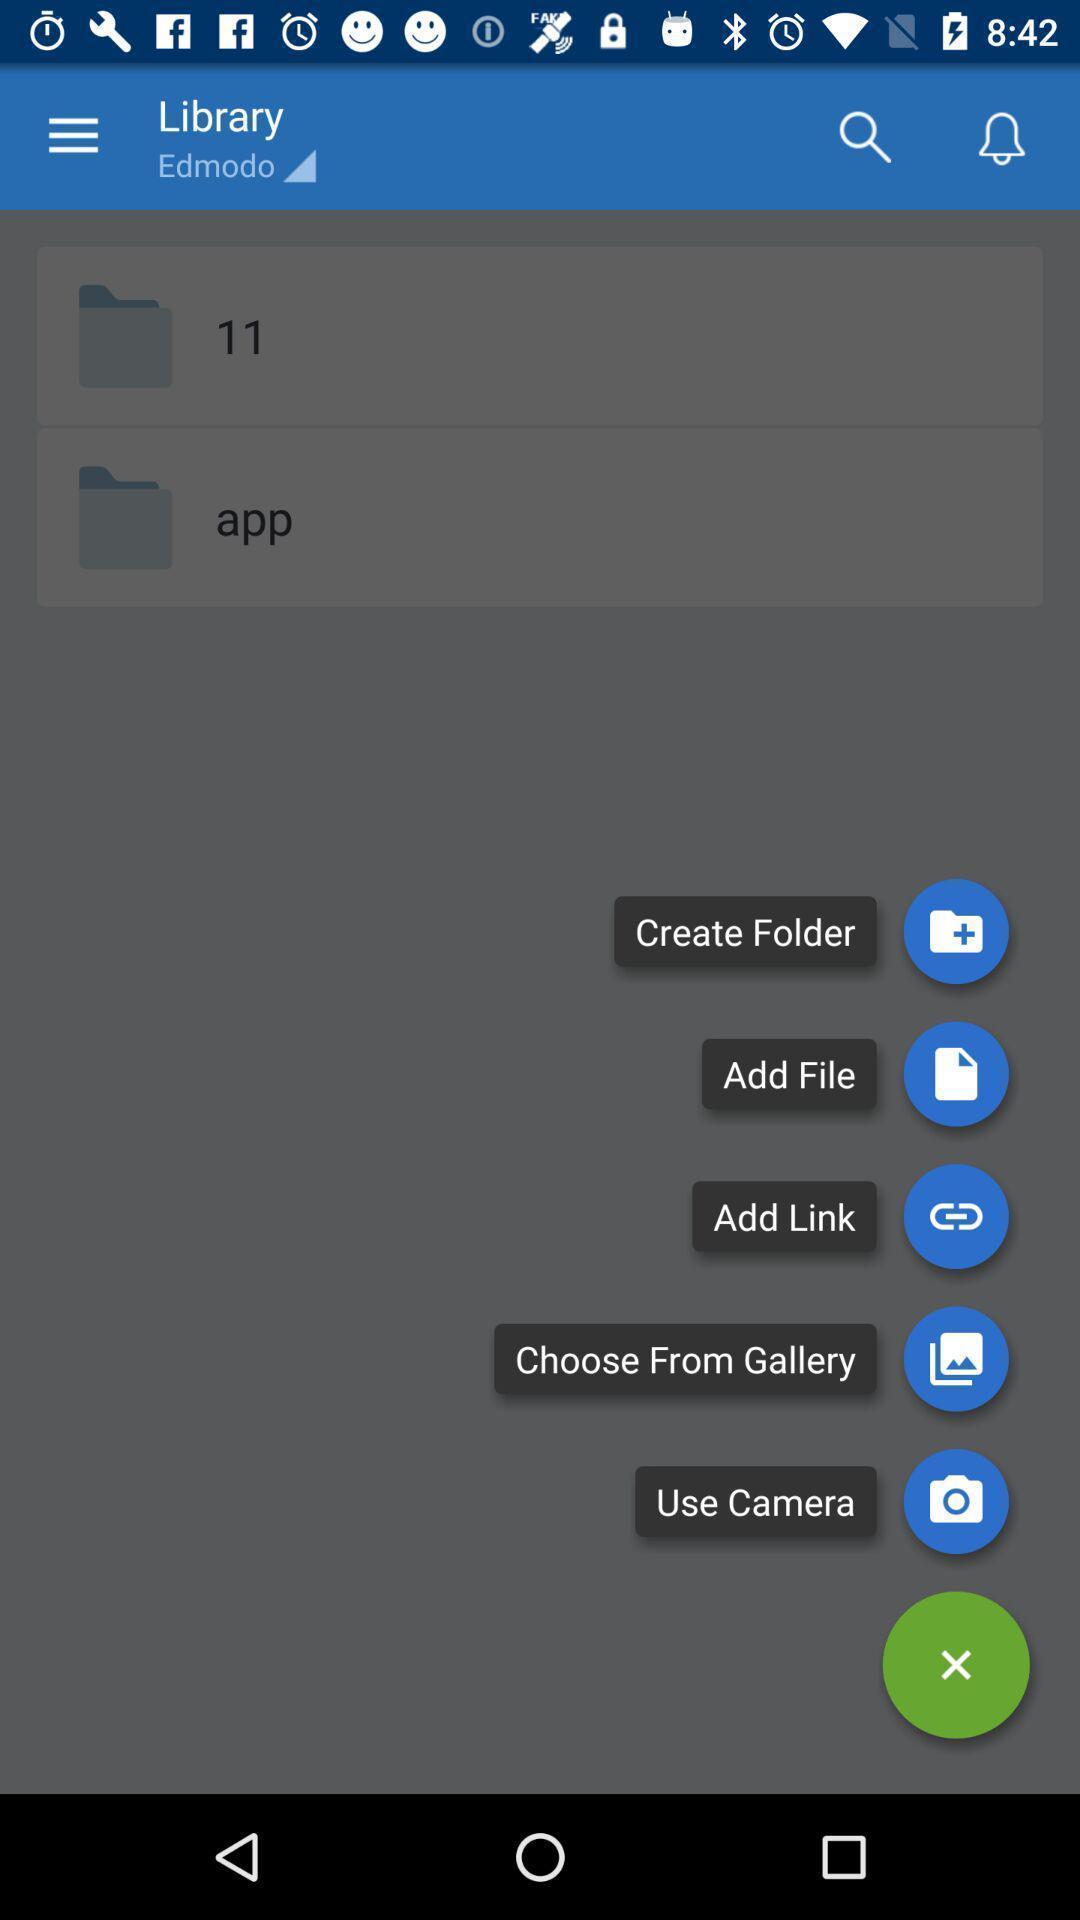Describe the visual elements of this screenshot. Popup displaying icons with names on an app. 